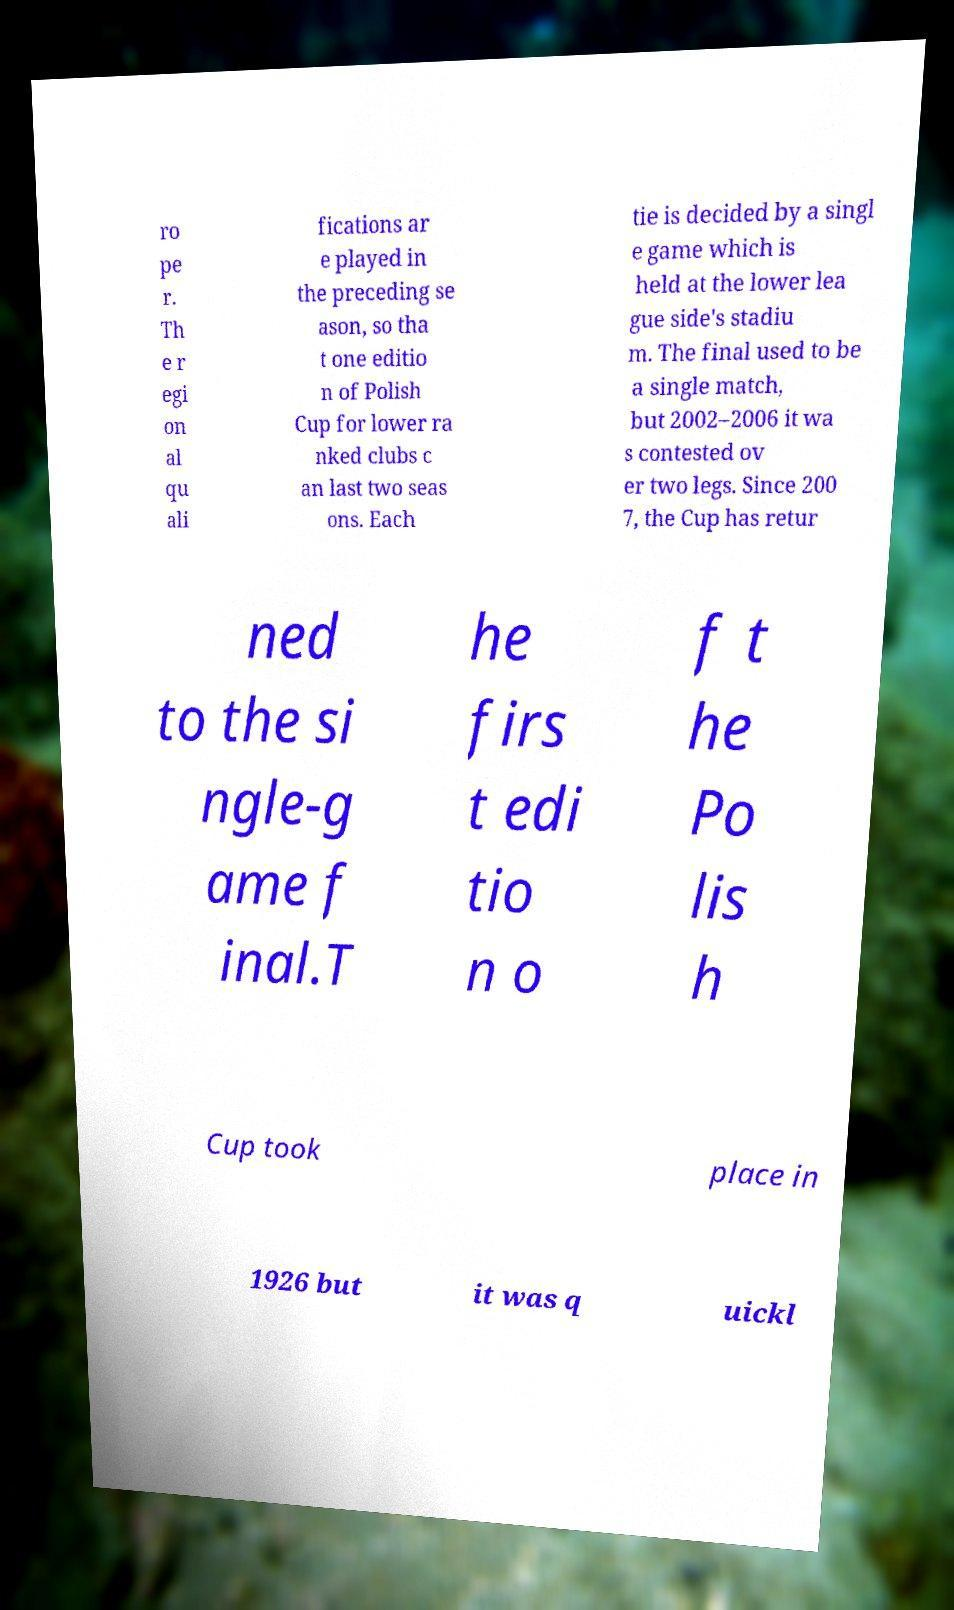I need the written content from this picture converted into text. Can you do that? ro pe r. Th e r egi on al qu ali fications ar e played in the preceding se ason, so tha t one editio n of Polish Cup for lower ra nked clubs c an last two seas ons. Each tie is decided by a singl e game which is held at the lower lea gue side's stadiu m. The final used to be a single match, but 2002–2006 it wa s contested ov er two legs. Since 200 7, the Cup has retur ned to the si ngle-g ame f inal.T he firs t edi tio n o f t he Po lis h Cup took place in 1926 but it was q uickl 